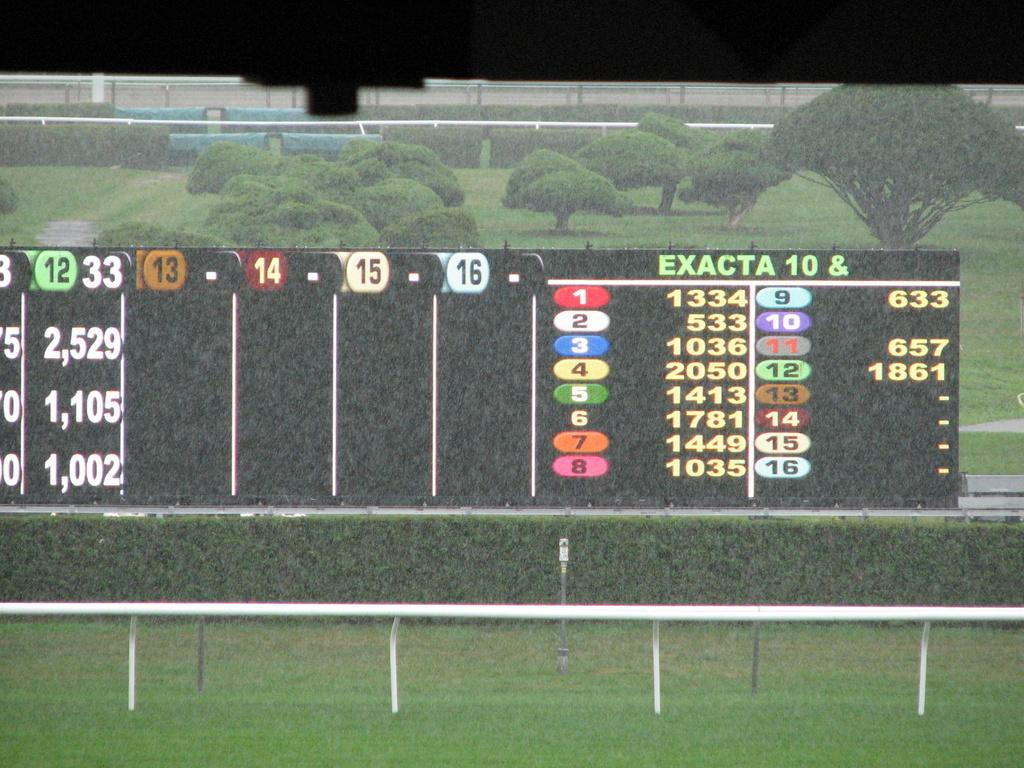<image>
Provide a brief description of the given image. A scoreboard on a field has the heading Exacta 10. 